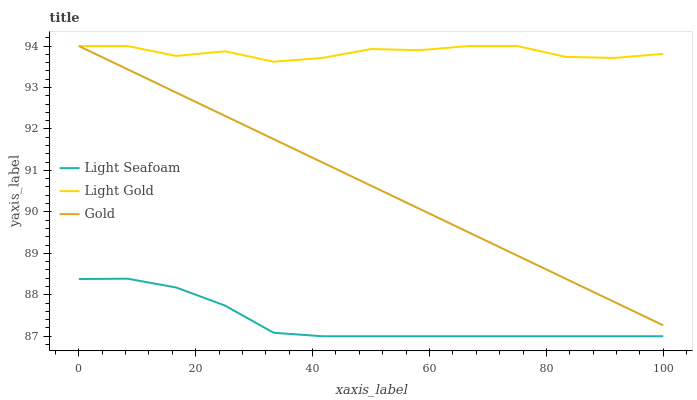Does Light Seafoam have the minimum area under the curve?
Answer yes or no. Yes. Does Light Gold have the maximum area under the curve?
Answer yes or no. Yes. Does Gold have the minimum area under the curve?
Answer yes or no. No. Does Gold have the maximum area under the curve?
Answer yes or no. No. Is Gold the smoothest?
Answer yes or no. Yes. Is Light Gold the roughest?
Answer yes or no. Yes. Is Light Gold the smoothest?
Answer yes or no. No. Is Gold the roughest?
Answer yes or no. No. Does Light Seafoam have the lowest value?
Answer yes or no. Yes. Does Gold have the lowest value?
Answer yes or no. No. Does Gold have the highest value?
Answer yes or no. Yes. Is Light Seafoam less than Light Gold?
Answer yes or no. Yes. Is Light Gold greater than Light Seafoam?
Answer yes or no. Yes. Does Light Gold intersect Gold?
Answer yes or no. Yes. Is Light Gold less than Gold?
Answer yes or no. No. Is Light Gold greater than Gold?
Answer yes or no. No. Does Light Seafoam intersect Light Gold?
Answer yes or no. No. 